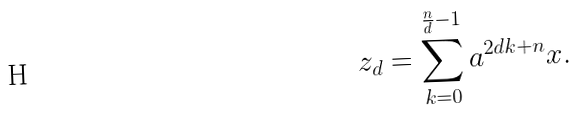Convert formula to latex. <formula><loc_0><loc_0><loc_500><loc_500>z _ { d } = \sum _ { k = 0 } ^ { \frac { n } { d } - 1 } a ^ { 2 d k + n } x .</formula> 